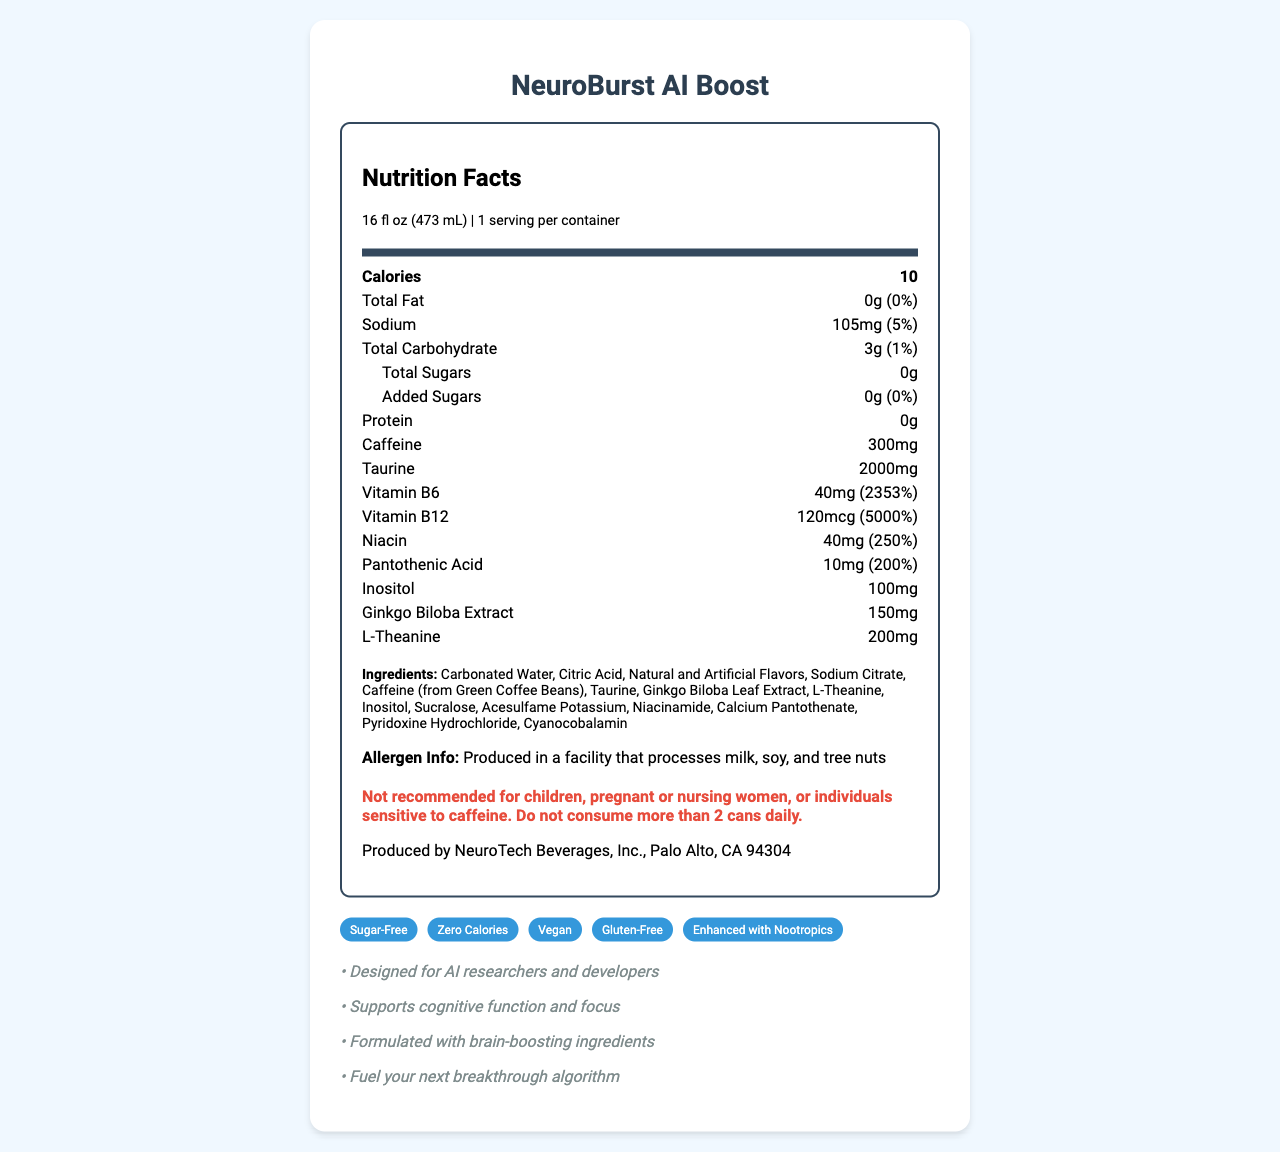what is the serving size? The serving size is directly mentioned under the product name at the top of the document.
Answer: 16 fl oz (473 mL) how many calories are in one serving? The calorie content per serving is clearly stated as 10 in the document.
Answer: 10 what is the amount of sodium per serving? The amount of sodium per serving is listed as 105mg in the nutrient information section.
Answer: 105mg what is the caffeine content in NeuroBurst AI Boost? The caffeine content is explicitly mentioned as 300mg in the nutrient information section.
Answer: 300mg are there any sugars in this energy drink? The Total Sugars section states 0g, including 0g of added sugars.
Answer: No what are the manufacturer's recommendations regarding the consumption of this drink? This information is found under the warning statement in the document.
Answer: Not recommended for children, pregnant or nursing women, or individuals sensitive to caffeine. Do not consume more than 2 cans daily. what is the main feature of NeuroBurst AI Boost? A. Sugar-Free B. High Protein C. Contains Dairy D. Rich in Fiber The document lists "Sugar-Free" as one of the special features of the beverage.
Answer: A. Sugar-Free which vitamin is present in the highest amount? i. Vitamin B6 ii. Vitamin B12 iii. Niacin iv. Pantothenic Acid Vitamin B12 is present in the highest amount with 5000% of the daily value.
Answer: ii. Vitamin B12 is this product safe for children? The warning statement explicitly says the product is not recommended for children.
Answer: No describe the primary features and benefits of NeuroBurst AI Boost The document features a comprehensive list of special features and marketing claims, as well as a detailed breakdown of ingredients and nutrients that highlight the beverage's cognitive benefits and its suitability for health-conscious consumers.
Answer: NeuroBurst AI Boost is an energy drink designed for AI researchers and developers. It is sugar-free, zero calories, vegan, gluten-free, and enhanced with nootropics. It contains brain-boosting ingredients like Caffeine, Taurine, Ginkgo Biloba Extract, L-Theanine, and significant amounts of Vitamin B6, B12, Niacin, and Pantothenic Acid. It supports cognitive function and focus and is marketed to fuel breakthroughs in algorithm development. how many calories are there in the entire container? The document only provides the calories per serving and states the serving size but doesn't confirm the quantity for the entire container beyond implying a single serving size.
Answer: Not enough information 